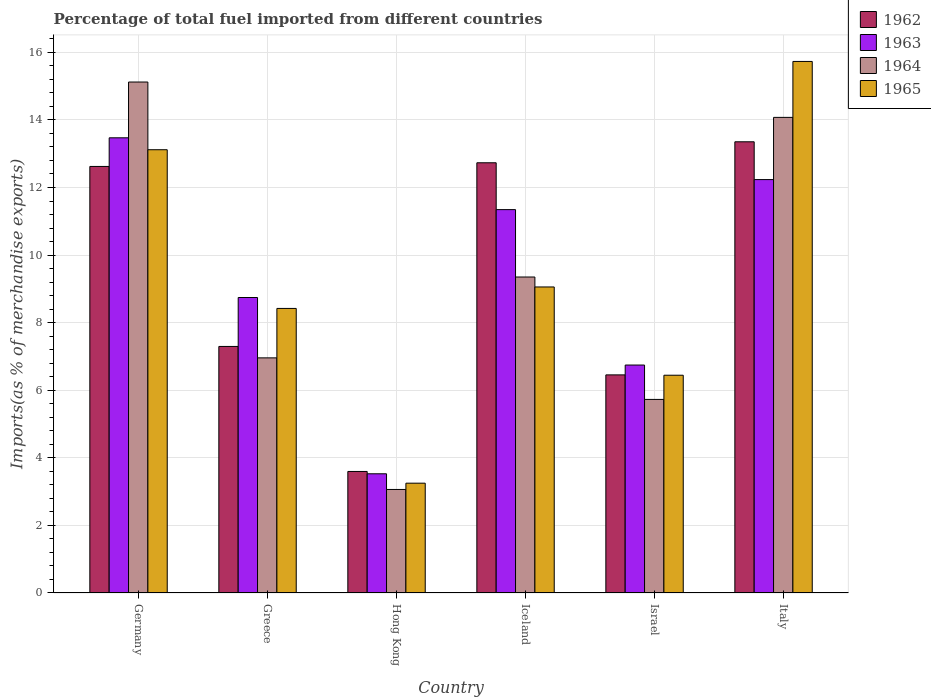How many different coloured bars are there?
Give a very brief answer. 4. How many groups of bars are there?
Your answer should be compact. 6. Are the number of bars per tick equal to the number of legend labels?
Offer a very short reply. Yes. Are the number of bars on each tick of the X-axis equal?
Your response must be concise. Yes. How many bars are there on the 2nd tick from the left?
Provide a short and direct response. 4. What is the label of the 4th group of bars from the left?
Make the answer very short. Iceland. What is the percentage of imports to different countries in 1964 in Greece?
Make the answer very short. 6.96. Across all countries, what is the maximum percentage of imports to different countries in 1964?
Provide a short and direct response. 15.12. Across all countries, what is the minimum percentage of imports to different countries in 1964?
Your answer should be compact. 3.06. In which country was the percentage of imports to different countries in 1962 minimum?
Offer a very short reply. Hong Kong. What is the total percentage of imports to different countries in 1962 in the graph?
Your answer should be very brief. 56.05. What is the difference between the percentage of imports to different countries in 1962 in Iceland and that in Italy?
Offer a very short reply. -0.62. What is the difference between the percentage of imports to different countries in 1965 in Israel and the percentage of imports to different countries in 1962 in Hong Kong?
Your answer should be very brief. 2.85. What is the average percentage of imports to different countries in 1965 per country?
Provide a short and direct response. 9.34. What is the difference between the percentage of imports to different countries of/in 1965 and percentage of imports to different countries of/in 1964 in Greece?
Your response must be concise. 1.46. What is the ratio of the percentage of imports to different countries in 1962 in Greece to that in Hong Kong?
Your answer should be compact. 2.03. Is the percentage of imports to different countries in 1962 in Germany less than that in Hong Kong?
Offer a very short reply. No. Is the difference between the percentage of imports to different countries in 1965 in Germany and Israel greater than the difference between the percentage of imports to different countries in 1964 in Germany and Israel?
Keep it short and to the point. No. What is the difference between the highest and the second highest percentage of imports to different countries in 1965?
Your answer should be very brief. -4.06. What is the difference between the highest and the lowest percentage of imports to different countries in 1964?
Ensure brevity in your answer.  12.06. In how many countries, is the percentage of imports to different countries in 1962 greater than the average percentage of imports to different countries in 1962 taken over all countries?
Your response must be concise. 3. Is it the case that in every country, the sum of the percentage of imports to different countries in 1963 and percentage of imports to different countries in 1965 is greater than the sum of percentage of imports to different countries in 1962 and percentage of imports to different countries in 1964?
Provide a short and direct response. No. What does the 2nd bar from the right in Israel represents?
Provide a short and direct response. 1964. Is it the case that in every country, the sum of the percentage of imports to different countries in 1963 and percentage of imports to different countries in 1965 is greater than the percentage of imports to different countries in 1964?
Your response must be concise. Yes. Are the values on the major ticks of Y-axis written in scientific E-notation?
Your response must be concise. No. Does the graph contain grids?
Ensure brevity in your answer.  Yes. How many legend labels are there?
Provide a short and direct response. 4. How are the legend labels stacked?
Your answer should be compact. Vertical. What is the title of the graph?
Your response must be concise. Percentage of total fuel imported from different countries. What is the label or title of the Y-axis?
Ensure brevity in your answer.  Imports(as % of merchandise exports). What is the Imports(as % of merchandise exports) in 1962 in Germany?
Your answer should be very brief. 12.62. What is the Imports(as % of merchandise exports) of 1963 in Germany?
Provide a succinct answer. 13.47. What is the Imports(as % of merchandise exports) of 1964 in Germany?
Your response must be concise. 15.12. What is the Imports(as % of merchandise exports) of 1965 in Germany?
Your response must be concise. 13.12. What is the Imports(as % of merchandise exports) of 1962 in Greece?
Your response must be concise. 7.3. What is the Imports(as % of merchandise exports) in 1963 in Greece?
Offer a very short reply. 8.74. What is the Imports(as % of merchandise exports) of 1964 in Greece?
Make the answer very short. 6.96. What is the Imports(as % of merchandise exports) in 1965 in Greece?
Keep it short and to the point. 8.42. What is the Imports(as % of merchandise exports) in 1962 in Hong Kong?
Provide a short and direct response. 3.6. What is the Imports(as % of merchandise exports) in 1963 in Hong Kong?
Offer a terse response. 3.53. What is the Imports(as % of merchandise exports) of 1964 in Hong Kong?
Offer a terse response. 3.06. What is the Imports(as % of merchandise exports) in 1965 in Hong Kong?
Your answer should be compact. 3.25. What is the Imports(as % of merchandise exports) of 1962 in Iceland?
Offer a very short reply. 12.73. What is the Imports(as % of merchandise exports) in 1963 in Iceland?
Your response must be concise. 11.35. What is the Imports(as % of merchandise exports) in 1964 in Iceland?
Give a very brief answer. 9.35. What is the Imports(as % of merchandise exports) of 1965 in Iceland?
Ensure brevity in your answer.  9.06. What is the Imports(as % of merchandise exports) of 1962 in Israel?
Make the answer very short. 6.45. What is the Imports(as % of merchandise exports) in 1963 in Israel?
Your answer should be very brief. 6.75. What is the Imports(as % of merchandise exports) of 1964 in Israel?
Provide a short and direct response. 5.73. What is the Imports(as % of merchandise exports) in 1965 in Israel?
Provide a succinct answer. 6.44. What is the Imports(as % of merchandise exports) of 1962 in Italy?
Provide a succinct answer. 13.35. What is the Imports(as % of merchandise exports) of 1963 in Italy?
Give a very brief answer. 12.23. What is the Imports(as % of merchandise exports) of 1964 in Italy?
Give a very brief answer. 14.07. What is the Imports(as % of merchandise exports) of 1965 in Italy?
Your response must be concise. 15.73. Across all countries, what is the maximum Imports(as % of merchandise exports) in 1962?
Your answer should be compact. 13.35. Across all countries, what is the maximum Imports(as % of merchandise exports) of 1963?
Your response must be concise. 13.47. Across all countries, what is the maximum Imports(as % of merchandise exports) of 1964?
Offer a terse response. 15.12. Across all countries, what is the maximum Imports(as % of merchandise exports) in 1965?
Your response must be concise. 15.73. Across all countries, what is the minimum Imports(as % of merchandise exports) in 1962?
Provide a succinct answer. 3.6. Across all countries, what is the minimum Imports(as % of merchandise exports) of 1963?
Provide a succinct answer. 3.53. Across all countries, what is the minimum Imports(as % of merchandise exports) in 1964?
Give a very brief answer. 3.06. Across all countries, what is the minimum Imports(as % of merchandise exports) of 1965?
Provide a short and direct response. 3.25. What is the total Imports(as % of merchandise exports) of 1962 in the graph?
Provide a succinct answer. 56.05. What is the total Imports(as % of merchandise exports) in 1963 in the graph?
Your answer should be compact. 56.07. What is the total Imports(as % of merchandise exports) of 1964 in the graph?
Make the answer very short. 54.3. What is the total Imports(as % of merchandise exports) of 1965 in the graph?
Provide a short and direct response. 56.02. What is the difference between the Imports(as % of merchandise exports) of 1962 in Germany and that in Greece?
Ensure brevity in your answer.  5.33. What is the difference between the Imports(as % of merchandise exports) of 1963 in Germany and that in Greece?
Give a very brief answer. 4.73. What is the difference between the Imports(as % of merchandise exports) of 1964 in Germany and that in Greece?
Your answer should be compact. 8.16. What is the difference between the Imports(as % of merchandise exports) of 1965 in Germany and that in Greece?
Offer a very short reply. 4.7. What is the difference between the Imports(as % of merchandise exports) of 1962 in Germany and that in Hong Kong?
Offer a very short reply. 9.03. What is the difference between the Imports(as % of merchandise exports) in 1963 in Germany and that in Hong Kong?
Provide a short and direct response. 9.94. What is the difference between the Imports(as % of merchandise exports) of 1964 in Germany and that in Hong Kong?
Give a very brief answer. 12.06. What is the difference between the Imports(as % of merchandise exports) in 1965 in Germany and that in Hong Kong?
Give a very brief answer. 9.87. What is the difference between the Imports(as % of merchandise exports) in 1962 in Germany and that in Iceland?
Make the answer very short. -0.11. What is the difference between the Imports(as % of merchandise exports) of 1963 in Germany and that in Iceland?
Offer a terse response. 2.13. What is the difference between the Imports(as % of merchandise exports) of 1964 in Germany and that in Iceland?
Your answer should be compact. 5.77. What is the difference between the Imports(as % of merchandise exports) of 1965 in Germany and that in Iceland?
Ensure brevity in your answer.  4.06. What is the difference between the Imports(as % of merchandise exports) of 1962 in Germany and that in Israel?
Your response must be concise. 6.17. What is the difference between the Imports(as % of merchandise exports) of 1963 in Germany and that in Israel?
Give a very brief answer. 6.72. What is the difference between the Imports(as % of merchandise exports) in 1964 in Germany and that in Israel?
Your response must be concise. 9.39. What is the difference between the Imports(as % of merchandise exports) in 1965 in Germany and that in Israel?
Offer a terse response. 6.67. What is the difference between the Imports(as % of merchandise exports) of 1962 in Germany and that in Italy?
Offer a very short reply. -0.73. What is the difference between the Imports(as % of merchandise exports) of 1963 in Germany and that in Italy?
Make the answer very short. 1.24. What is the difference between the Imports(as % of merchandise exports) of 1964 in Germany and that in Italy?
Your answer should be very brief. 1.05. What is the difference between the Imports(as % of merchandise exports) in 1965 in Germany and that in Italy?
Give a very brief answer. -2.61. What is the difference between the Imports(as % of merchandise exports) of 1962 in Greece and that in Hong Kong?
Offer a terse response. 3.7. What is the difference between the Imports(as % of merchandise exports) in 1963 in Greece and that in Hong Kong?
Make the answer very short. 5.22. What is the difference between the Imports(as % of merchandise exports) in 1964 in Greece and that in Hong Kong?
Ensure brevity in your answer.  3.89. What is the difference between the Imports(as % of merchandise exports) of 1965 in Greece and that in Hong Kong?
Ensure brevity in your answer.  5.17. What is the difference between the Imports(as % of merchandise exports) of 1962 in Greece and that in Iceland?
Offer a terse response. -5.44. What is the difference between the Imports(as % of merchandise exports) of 1963 in Greece and that in Iceland?
Keep it short and to the point. -2.6. What is the difference between the Imports(as % of merchandise exports) in 1964 in Greece and that in Iceland?
Your answer should be very brief. -2.39. What is the difference between the Imports(as % of merchandise exports) in 1965 in Greece and that in Iceland?
Your response must be concise. -0.64. What is the difference between the Imports(as % of merchandise exports) in 1962 in Greece and that in Israel?
Offer a terse response. 0.84. What is the difference between the Imports(as % of merchandise exports) of 1963 in Greece and that in Israel?
Give a very brief answer. 2. What is the difference between the Imports(as % of merchandise exports) in 1964 in Greece and that in Israel?
Give a very brief answer. 1.23. What is the difference between the Imports(as % of merchandise exports) of 1965 in Greece and that in Israel?
Your response must be concise. 1.98. What is the difference between the Imports(as % of merchandise exports) in 1962 in Greece and that in Italy?
Provide a succinct answer. -6.06. What is the difference between the Imports(as % of merchandise exports) of 1963 in Greece and that in Italy?
Offer a terse response. -3.49. What is the difference between the Imports(as % of merchandise exports) in 1964 in Greece and that in Italy?
Offer a terse response. -7.12. What is the difference between the Imports(as % of merchandise exports) of 1965 in Greece and that in Italy?
Give a very brief answer. -7.31. What is the difference between the Imports(as % of merchandise exports) of 1962 in Hong Kong and that in Iceland?
Your answer should be compact. -9.13. What is the difference between the Imports(as % of merchandise exports) in 1963 in Hong Kong and that in Iceland?
Make the answer very short. -7.82. What is the difference between the Imports(as % of merchandise exports) in 1964 in Hong Kong and that in Iceland?
Your response must be concise. -6.29. What is the difference between the Imports(as % of merchandise exports) of 1965 in Hong Kong and that in Iceland?
Offer a very short reply. -5.81. What is the difference between the Imports(as % of merchandise exports) of 1962 in Hong Kong and that in Israel?
Offer a very short reply. -2.86. What is the difference between the Imports(as % of merchandise exports) in 1963 in Hong Kong and that in Israel?
Offer a terse response. -3.22. What is the difference between the Imports(as % of merchandise exports) of 1964 in Hong Kong and that in Israel?
Your answer should be compact. -2.66. What is the difference between the Imports(as % of merchandise exports) of 1965 in Hong Kong and that in Israel?
Your response must be concise. -3.19. What is the difference between the Imports(as % of merchandise exports) of 1962 in Hong Kong and that in Italy?
Provide a short and direct response. -9.76. What is the difference between the Imports(as % of merchandise exports) of 1963 in Hong Kong and that in Italy?
Provide a succinct answer. -8.71. What is the difference between the Imports(as % of merchandise exports) of 1964 in Hong Kong and that in Italy?
Your answer should be compact. -11.01. What is the difference between the Imports(as % of merchandise exports) in 1965 in Hong Kong and that in Italy?
Your response must be concise. -12.48. What is the difference between the Imports(as % of merchandise exports) in 1962 in Iceland and that in Israel?
Your answer should be compact. 6.28. What is the difference between the Imports(as % of merchandise exports) of 1963 in Iceland and that in Israel?
Ensure brevity in your answer.  4.6. What is the difference between the Imports(as % of merchandise exports) in 1964 in Iceland and that in Israel?
Your response must be concise. 3.62. What is the difference between the Imports(as % of merchandise exports) in 1965 in Iceland and that in Israel?
Your answer should be very brief. 2.61. What is the difference between the Imports(as % of merchandise exports) of 1962 in Iceland and that in Italy?
Your answer should be compact. -0.62. What is the difference between the Imports(as % of merchandise exports) in 1963 in Iceland and that in Italy?
Offer a terse response. -0.89. What is the difference between the Imports(as % of merchandise exports) of 1964 in Iceland and that in Italy?
Offer a terse response. -4.72. What is the difference between the Imports(as % of merchandise exports) in 1965 in Iceland and that in Italy?
Provide a succinct answer. -6.67. What is the difference between the Imports(as % of merchandise exports) in 1962 in Israel and that in Italy?
Keep it short and to the point. -6.9. What is the difference between the Imports(as % of merchandise exports) in 1963 in Israel and that in Italy?
Make the answer very short. -5.49. What is the difference between the Imports(as % of merchandise exports) of 1964 in Israel and that in Italy?
Your answer should be very brief. -8.35. What is the difference between the Imports(as % of merchandise exports) in 1965 in Israel and that in Italy?
Provide a succinct answer. -9.29. What is the difference between the Imports(as % of merchandise exports) of 1962 in Germany and the Imports(as % of merchandise exports) of 1963 in Greece?
Your answer should be compact. 3.88. What is the difference between the Imports(as % of merchandise exports) of 1962 in Germany and the Imports(as % of merchandise exports) of 1964 in Greece?
Ensure brevity in your answer.  5.66. What is the difference between the Imports(as % of merchandise exports) in 1962 in Germany and the Imports(as % of merchandise exports) in 1965 in Greece?
Offer a very short reply. 4.2. What is the difference between the Imports(as % of merchandise exports) in 1963 in Germany and the Imports(as % of merchandise exports) in 1964 in Greece?
Your answer should be compact. 6.51. What is the difference between the Imports(as % of merchandise exports) of 1963 in Germany and the Imports(as % of merchandise exports) of 1965 in Greece?
Keep it short and to the point. 5.05. What is the difference between the Imports(as % of merchandise exports) in 1964 in Germany and the Imports(as % of merchandise exports) in 1965 in Greece?
Offer a terse response. 6.7. What is the difference between the Imports(as % of merchandise exports) of 1962 in Germany and the Imports(as % of merchandise exports) of 1963 in Hong Kong?
Keep it short and to the point. 9.1. What is the difference between the Imports(as % of merchandise exports) of 1962 in Germany and the Imports(as % of merchandise exports) of 1964 in Hong Kong?
Your answer should be very brief. 9.56. What is the difference between the Imports(as % of merchandise exports) in 1962 in Germany and the Imports(as % of merchandise exports) in 1965 in Hong Kong?
Give a very brief answer. 9.37. What is the difference between the Imports(as % of merchandise exports) of 1963 in Germany and the Imports(as % of merchandise exports) of 1964 in Hong Kong?
Your answer should be very brief. 10.41. What is the difference between the Imports(as % of merchandise exports) of 1963 in Germany and the Imports(as % of merchandise exports) of 1965 in Hong Kong?
Ensure brevity in your answer.  10.22. What is the difference between the Imports(as % of merchandise exports) of 1964 in Germany and the Imports(as % of merchandise exports) of 1965 in Hong Kong?
Give a very brief answer. 11.87. What is the difference between the Imports(as % of merchandise exports) of 1962 in Germany and the Imports(as % of merchandise exports) of 1963 in Iceland?
Your answer should be very brief. 1.28. What is the difference between the Imports(as % of merchandise exports) in 1962 in Germany and the Imports(as % of merchandise exports) in 1964 in Iceland?
Make the answer very short. 3.27. What is the difference between the Imports(as % of merchandise exports) of 1962 in Germany and the Imports(as % of merchandise exports) of 1965 in Iceland?
Provide a short and direct response. 3.57. What is the difference between the Imports(as % of merchandise exports) of 1963 in Germany and the Imports(as % of merchandise exports) of 1964 in Iceland?
Offer a terse response. 4.12. What is the difference between the Imports(as % of merchandise exports) of 1963 in Germany and the Imports(as % of merchandise exports) of 1965 in Iceland?
Your answer should be very brief. 4.41. What is the difference between the Imports(as % of merchandise exports) in 1964 in Germany and the Imports(as % of merchandise exports) in 1965 in Iceland?
Offer a very short reply. 6.06. What is the difference between the Imports(as % of merchandise exports) in 1962 in Germany and the Imports(as % of merchandise exports) in 1963 in Israel?
Ensure brevity in your answer.  5.88. What is the difference between the Imports(as % of merchandise exports) of 1962 in Germany and the Imports(as % of merchandise exports) of 1964 in Israel?
Offer a very short reply. 6.89. What is the difference between the Imports(as % of merchandise exports) of 1962 in Germany and the Imports(as % of merchandise exports) of 1965 in Israel?
Offer a terse response. 6.18. What is the difference between the Imports(as % of merchandise exports) in 1963 in Germany and the Imports(as % of merchandise exports) in 1964 in Israel?
Offer a very short reply. 7.74. What is the difference between the Imports(as % of merchandise exports) in 1963 in Germany and the Imports(as % of merchandise exports) in 1965 in Israel?
Provide a succinct answer. 7.03. What is the difference between the Imports(as % of merchandise exports) of 1964 in Germany and the Imports(as % of merchandise exports) of 1965 in Israel?
Your response must be concise. 8.68. What is the difference between the Imports(as % of merchandise exports) of 1962 in Germany and the Imports(as % of merchandise exports) of 1963 in Italy?
Offer a terse response. 0.39. What is the difference between the Imports(as % of merchandise exports) of 1962 in Germany and the Imports(as % of merchandise exports) of 1964 in Italy?
Your answer should be compact. -1.45. What is the difference between the Imports(as % of merchandise exports) in 1962 in Germany and the Imports(as % of merchandise exports) in 1965 in Italy?
Ensure brevity in your answer.  -3.11. What is the difference between the Imports(as % of merchandise exports) of 1963 in Germany and the Imports(as % of merchandise exports) of 1964 in Italy?
Provide a succinct answer. -0.6. What is the difference between the Imports(as % of merchandise exports) in 1963 in Germany and the Imports(as % of merchandise exports) in 1965 in Italy?
Offer a very short reply. -2.26. What is the difference between the Imports(as % of merchandise exports) of 1964 in Germany and the Imports(as % of merchandise exports) of 1965 in Italy?
Your answer should be compact. -0.61. What is the difference between the Imports(as % of merchandise exports) of 1962 in Greece and the Imports(as % of merchandise exports) of 1963 in Hong Kong?
Give a very brief answer. 3.77. What is the difference between the Imports(as % of merchandise exports) of 1962 in Greece and the Imports(as % of merchandise exports) of 1964 in Hong Kong?
Your answer should be compact. 4.23. What is the difference between the Imports(as % of merchandise exports) of 1962 in Greece and the Imports(as % of merchandise exports) of 1965 in Hong Kong?
Make the answer very short. 4.05. What is the difference between the Imports(as % of merchandise exports) of 1963 in Greece and the Imports(as % of merchandise exports) of 1964 in Hong Kong?
Give a very brief answer. 5.68. What is the difference between the Imports(as % of merchandise exports) in 1963 in Greece and the Imports(as % of merchandise exports) in 1965 in Hong Kong?
Give a very brief answer. 5.49. What is the difference between the Imports(as % of merchandise exports) of 1964 in Greece and the Imports(as % of merchandise exports) of 1965 in Hong Kong?
Offer a terse response. 3.71. What is the difference between the Imports(as % of merchandise exports) in 1962 in Greece and the Imports(as % of merchandise exports) in 1963 in Iceland?
Ensure brevity in your answer.  -4.05. What is the difference between the Imports(as % of merchandise exports) in 1962 in Greece and the Imports(as % of merchandise exports) in 1964 in Iceland?
Give a very brief answer. -2.06. What is the difference between the Imports(as % of merchandise exports) in 1962 in Greece and the Imports(as % of merchandise exports) in 1965 in Iceland?
Make the answer very short. -1.76. What is the difference between the Imports(as % of merchandise exports) in 1963 in Greece and the Imports(as % of merchandise exports) in 1964 in Iceland?
Provide a succinct answer. -0.61. What is the difference between the Imports(as % of merchandise exports) in 1963 in Greece and the Imports(as % of merchandise exports) in 1965 in Iceland?
Keep it short and to the point. -0.31. What is the difference between the Imports(as % of merchandise exports) in 1964 in Greece and the Imports(as % of merchandise exports) in 1965 in Iceland?
Give a very brief answer. -2.1. What is the difference between the Imports(as % of merchandise exports) of 1962 in Greece and the Imports(as % of merchandise exports) of 1963 in Israel?
Your answer should be very brief. 0.55. What is the difference between the Imports(as % of merchandise exports) in 1962 in Greece and the Imports(as % of merchandise exports) in 1964 in Israel?
Offer a very short reply. 1.57. What is the difference between the Imports(as % of merchandise exports) of 1962 in Greece and the Imports(as % of merchandise exports) of 1965 in Israel?
Offer a very short reply. 0.85. What is the difference between the Imports(as % of merchandise exports) of 1963 in Greece and the Imports(as % of merchandise exports) of 1964 in Israel?
Provide a short and direct response. 3.02. What is the difference between the Imports(as % of merchandise exports) in 1964 in Greece and the Imports(as % of merchandise exports) in 1965 in Israel?
Your answer should be compact. 0.51. What is the difference between the Imports(as % of merchandise exports) in 1962 in Greece and the Imports(as % of merchandise exports) in 1963 in Italy?
Offer a very short reply. -4.94. What is the difference between the Imports(as % of merchandise exports) in 1962 in Greece and the Imports(as % of merchandise exports) in 1964 in Italy?
Provide a short and direct response. -6.78. What is the difference between the Imports(as % of merchandise exports) in 1962 in Greece and the Imports(as % of merchandise exports) in 1965 in Italy?
Keep it short and to the point. -8.43. What is the difference between the Imports(as % of merchandise exports) of 1963 in Greece and the Imports(as % of merchandise exports) of 1964 in Italy?
Offer a terse response. -5.33. What is the difference between the Imports(as % of merchandise exports) of 1963 in Greece and the Imports(as % of merchandise exports) of 1965 in Italy?
Offer a terse response. -6.99. What is the difference between the Imports(as % of merchandise exports) of 1964 in Greece and the Imports(as % of merchandise exports) of 1965 in Italy?
Your answer should be very brief. -8.77. What is the difference between the Imports(as % of merchandise exports) in 1962 in Hong Kong and the Imports(as % of merchandise exports) in 1963 in Iceland?
Your response must be concise. -7.75. What is the difference between the Imports(as % of merchandise exports) of 1962 in Hong Kong and the Imports(as % of merchandise exports) of 1964 in Iceland?
Ensure brevity in your answer.  -5.75. What is the difference between the Imports(as % of merchandise exports) of 1962 in Hong Kong and the Imports(as % of merchandise exports) of 1965 in Iceland?
Provide a succinct answer. -5.46. What is the difference between the Imports(as % of merchandise exports) in 1963 in Hong Kong and the Imports(as % of merchandise exports) in 1964 in Iceland?
Make the answer very short. -5.82. What is the difference between the Imports(as % of merchandise exports) in 1963 in Hong Kong and the Imports(as % of merchandise exports) in 1965 in Iceland?
Provide a short and direct response. -5.53. What is the difference between the Imports(as % of merchandise exports) in 1964 in Hong Kong and the Imports(as % of merchandise exports) in 1965 in Iceland?
Keep it short and to the point. -5.99. What is the difference between the Imports(as % of merchandise exports) in 1962 in Hong Kong and the Imports(as % of merchandise exports) in 1963 in Israel?
Provide a short and direct response. -3.15. What is the difference between the Imports(as % of merchandise exports) in 1962 in Hong Kong and the Imports(as % of merchandise exports) in 1964 in Israel?
Offer a very short reply. -2.13. What is the difference between the Imports(as % of merchandise exports) in 1962 in Hong Kong and the Imports(as % of merchandise exports) in 1965 in Israel?
Make the answer very short. -2.85. What is the difference between the Imports(as % of merchandise exports) of 1963 in Hong Kong and the Imports(as % of merchandise exports) of 1964 in Israel?
Your answer should be compact. -2.2. What is the difference between the Imports(as % of merchandise exports) in 1963 in Hong Kong and the Imports(as % of merchandise exports) in 1965 in Israel?
Your answer should be very brief. -2.92. What is the difference between the Imports(as % of merchandise exports) in 1964 in Hong Kong and the Imports(as % of merchandise exports) in 1965 in Israel?
Provide a succinct answer. -3.38. What is the difference between the Imports(as % of merchandise exports) in 1962 in Hong Kong and the Imports(as % of merchandise exports) in 1963 in Italy?
Offer a terse response. -8.64. What is the difference between the Imports(as % of merchandise exports) in 1962 in Hong Kong and the Imports(as % of merchandise exports) in 1964 in Italy?
Provide a short and direct response. -10.48. What is the difference between the Imports(as % of merchandise exports) of 1962 in Hong Kong and the Imports(as % of merchandise exports) of 1965 in Italy?
Offer a very short reply. -12.13. What is the difference between the Imports(as % of merchandise exports) of 1963 in Hong Kong and the Imports(as % of merchandise exports) of 1964 in Italy?
Provide a succinct answer. -10.55. What is the difference between the Imports(as % of merchandise exports) of 1963 in Hong Kong and the Imports(as % of merchandise exports) of 1965 in Italy?
Offer a terse response. -12.2. What is the difference between the Imports(as % of merchandise exports) of 1964 in Hong Kong and the Imports(as % of merchandise exports) of 1965 in Italy?
Make the answer very short. -12.67. What is the difference between the Imports(as % of merchandise exports) of 1962 in Iceland and the Imports(as % of merchandise exports) of 1963 in Israel?
Provide a short and direct response. 5.99. What is the difference between the Imports(as % of merchandise exports) in 1962 in Iceland and the Imports(as % of merchandise exports) in 1964 in Israel?
Ensure brevity in your answer.  7. What is the difference between the Imports(as % of merchandise exports) of 1962 in Iceland and the Imports(as % of merchandise exports) of 1965 in Israel?
Give a very brief answer. 6.29. What is the difference between the Imports(as % of merchandise exports) of 1963 in Iceland and the Imports(as % of merchandise exports) of 1964 in Israel?
Your response must be concise. 5.62. What is the difference between the Imports(as % of merchandise exports) of 1963 in Iceland and the Imports(as % of merchandise exports) of 1965 in Israel?
Provide a short and direct response. 4.9. What is the difference between the Imports(as % of merchandise exports) of 1964 in Iceland and the Imports(as % of merchandise exports) of 1965 in Israel?
Provide a succinct answer. 2.91. What is the difference between the Imports(as % of merchandise exports) of 1962 in Iceland and the Imports(as % of merchandise exports) of 1963 in Italy?
Your response must be concise. 0.5. What is the difference between the Imports(as % of merchandise exports) of 1962 in Iceland and the Imports(as % of merchandise exports) of 1964 in Italy?
Ensure brevity in your answer.  -1.34. What is the difference between the Imports(as % of merchandise exports) in 1962 in Iceland and the Imports(as % of merchandise exports) in 1965 in Italy?
Ensure brevity in your answer.  -3. What is the difference between the Imports(as % of merchandise exports) in 1963 in Iceland and the Imports(as % of merchandise exports) in 1964 in Italy?
Your answer should be very brief. -2.73. What is the difference between the Imports(as % of merchandise exports) of 1963 in Iceland and the Imports(as % of merchandise exports) of 1965 in Italy?
Make the answer very short. -4.38. What is the difference between the Imports(as % of merchandise exports) of 1964 in Iceland and the Imports(as % of merchandise exports) of 1965 in Italy?
Keep it short and to the point. -6.38. What is the difference between the Imports(as % of merchandise exports) of 1962 in Israel and the Imports(as % of merchandise exports) of 1963 in Italy?
Make the answer very short. -5.78. What is the difference between the Imports(as % of merchandise exports) of 1962 in Israel and the Imports(as % of merchandise exports) of 1964 in Italy?
Provide a succinct answer. -7.62. What is the difference between the Imports(as % of merchandise exports) of 1962 in Israel and the Imports(as % of merchandise exports) of 1965 in Italy?
Provide a succinct answer. -9.28. What is the difference between the Imports(as % of merchandise exports) in 1963 in Israel and the Imports(as % of merchandise exports) in 1964 in Italy?
Your response must be concise. -7.33. What is the difference between the Imports(as % of merchandise exports) in 1963 in Israel and the Imports(as % of merchandise exports) in 1965 in Italy?
Your answer should be compact. -8.98. What is the difference between the Imports(as % of merchandise exports) of 1964 in Israel and the Imports(as % of merchandise exports) of 1965 in Italy?
Give a very brief answer. -10. What is the average Imports(as % of merchandise exports) of 1962 per country?
Provide a succinct answer. 9.34. What is the average Imports(as % of merchandise exports) in 1963 per country?
Ensure brevity in your answer.  9.34. What is the average Imports(as % of merchandise exports) in 1964 per country?
Make the answer very short. 9.05. What is the average Imports(as % of merchandise exports) of 1965 per country?
Keep it short and to the point. 9.34. What is the difference between the Imports(as % of merchandise exports) of 1962 and Imports(as % of merchandise exports) of 1963 in Germany?
Keep it short and to the point. -0.85. What is the difference between the Imports(as % of merchandise exports) in 1962 and Imports(as % of merchandise exports) in 1964 in Germany?
Provide a short and direct response. -2.5. What is the difference between the Imports(as % of merchandise exports) of 1962 and Imports(as % of merchandise exports) of 1965 in Germany?
Your answer should be compact. -0.49. What is the difference between the Imports(as % of merchandise exports) of 1963 and Imports(as % of merchandise exports) of 1964 in Germany?
Provide a succinct answer. -1.65. What is the difference between the Imports(as % of merchandise exports) in 1963 and Imports(as % of merchandise exports) in 1965 in Germany?
Provide a short and direct response. 0.35. What is the difference between the Imports(as % of merchandise exports) of 1964 and Imports(as % of merchandise exports) of 1965 in Germany?
Give a very brief answer. 2. What is the difference between the Imports(as % of merchandise exports) of 1962 and Imports(as % of merchandise exports) of 1963 in Greece?
Provide a succinct answer. -1.45. What is the difference between the Imports(as % of merchandise exports) of 1962 and Imports(as % of merchandise exports) of 1964 in Greece?
Offer a very short reply. 0.34. What is the difference between the Imports(as % of merchandise exports) in 1962 and Imports(as % of merchandise exports) in 1965 in Greece?
Ensure brevity in your answer.  -1.13. What is the difference between the Imports(as % of merchandise exports) of 1963 and Imports(as % of merchandise exports) of 1964 in Greece?
Ensure brevity in your answer.  1.79. What is the difference between the Imports(as % of merchandise exports) in 1963 and Imports(as % of merchandise exports) in 1965 in Greece?
Offer a very short reply. 0.32. What is the difference between the Imports(as % of merchandise exports) in 1964 and Imports(as % of merchandise exports) in 1965 in Greece?
Give a very brief answer. -1.46. What is the difference between the Imports(as % of merchandise exports) in 1962 and Imports(as % of merchandise exports) in 1963 in Hong Kong?
Offer a very short reply. 0.07. What is the difference between the Imports(as % of merchandise exports) of 1962 and Imports(as % of merchandise exports) of 1964 in Hong Kong?
Give a very brief answer. 0.53. What is the difference between the Imports(as % of merchandise exports) in 1962 and Imports(as % of merchandise exports) in 1965 in Hong Kong?
Offer a very short reply. 0.35. What is the difference between the Imports(as % of merchandise exports) of 1963 and Imports(as % of merchandise exports) of 1964 in Hong Kong?
Give a very brief answer. 0.46. What is the difference between the Imports(as % of merchandise exports) in 1963 and Imports(as % of merchandise exports) in 1965 in Hong Kong?
Your answer should be compact. 0.28. What is the difference between the Imports(as % of merchandise exports) of 1964 and Imports(as % of merchandise exports) of 1965 in Hong Kong?
Your response must be concise. -0.19. What is the difference between the Imports(as % of merchandise exports) of 1962 and Imports(as % of merchandise exports) of 1963 in Iceland?
Your response must be concise. 1.39. What is the difference between the Imports(as % of merchandise exports) in 1962 and Imports(as % of merchandise exports) in 1964 in Iceland?
Give a very brief answer. 3.38. What is the difference between the Imports(as % of merchandise exports) of 1962 and Imports(as % of merchandise exports) of 1965 in Iceland?
Make the answer very short. 3.67. What is the difference between the Imports(as % of merchandise exports) of 1963 and Imports(as % of merchandise exports) of 1964 in Iceland?
Offer a very short reply. 1.99. What is the difference between the Imports(as % of merchandise exports) of 1963 and Imports(as % of merchandise exports) of 1965 in Iceland?
Your response must be concise. 2.29. What is the difference between the Imports(as % of merchandise exports) of 1964 and Imports(as % of merchandise exports) of 1965 in Iceland?
Your answer should be very brief. 0.29. What is the difference between the Imports(as % of merchandise exports) of 1962 and Imports(as % of merchandise exports) of 1963 in Israel?
Provide a succinct answer. -0.29. What is the difference between the Imports(as % of merchandise exports) of 1962 and Imports(as % of merchandise exports) of 1964 in Israel?
Provide a succinct answer. 0.73. What is the difference between the Imports(as % of merchandise exports) of 1962 and Imports(as % of merchandise exports) of 1965 in Israel?
Offer a terse response. 0.01. What is the difference between the Imports(as % of merchandise exports) in 1963 and Imports(as % of merchandise exports) in 1964 in Israel?
Your response must be concise. 1.02. What is the difference between the Imports(as % of merchandise exports) in 1963 and Imports(as % of merchandise exports) in 1965 in Israel?
Offer a terse response. 0.3. What is the difference between the Imports(as % of merchandise exports) in 1964 and Imports(as % of merchandise exports) in 1965 in Israel?
Ensure brevity in your answer.  -0.72. What is the difference between the Imports(as % of merchandise exports) of 1962 and Imports(as % of merchandise exports) of 1963 in Italy?
Provide a succinct answer. 1.12. What is the difference between the Imports(as % of merchandise exports) of 1962 and Imports(as % of merchandise exports) of 1964 in Italy?
Provide a short and direct response. -0.72. What is the difference between the Imports(as % of merchandise exports) in 1962 and Imports(as % of merchandise exports) in 1965 in Italy?
Keep it short and to the point. -2.38. What is the difference between the Imports(as % of merchandise exports) in 1963 and Imports(as % of merchandise exports) in 1964 in Italy?
Offer a terse response. -1.84. What is the difference between the Imports(as % of merchandise exports) of 1963 and Imports(as % of merchandise exports) of 1965 in Italy?
Your answer should be compact. -3.5. What is the difference between the Imports(as % of merchandise exports) in 1964 and Imports(as % of merchandise exports) in 1965 in Italy?
Ensure brevity in your answer.  -1.65. What is the ratio of the Imports(as % of merchandise exports) in 1962 in Germany to that in Greece?
Your answer should be very brief. 1.73. What is the ratio of the Imports(as % of merchandise exports) in 1963 in Germany to that in Greece?
Ensure brevity in your answer.  1.54. What is the ratio of the Imports(as % of merchandise exports) in 1964 in Germany to that in Greece?
Provide a succinct answer. 2.17. What is the ratio of the Imports(as % of merchandise exports) in 1965 in Germany to that in Greece?
Offer a very short reply. 1.56. What is the ratio of the Imports(as % of merchandise exports) of 1962 in Germany to that in Hong Kong?
Your answer should be compact. 3.51. What is the ratio of the Imports(as % of merchandise exports) in 1963 in Germany to that in Hong Kong?
Provide a succinct answer. 3.82. What is the ratio of the Imports(as % of merchandise exports) of 1964 in Germany to that in Hong Kong?
Offer a very short reply. 4.94. What is the ratio of the Imports(as % of merchandise exports) of 1965 in Germany to that in Hong Kong?
Ensure brevity in your answer.  4.04. What is the ratio of the Imports(as % of merchandise exports) in 1963 in Germany to that in Iceland?
Keep it short and to the point. 1.19. What is the ratio of the Imports(as % of merchandise exports) in 1964 in Germany to that in Iceland?
Your answer should be very brief. 1.62. What is the ratio of the Imports(as % of merchandise exports) of 1965 in Germany to that in Iceland?
Make the answer very short. 1.45. What is the ratio of the Imports(as % of merchandise exports) in 1962 in Germany to that in Israel?
Give a very brief answer. 1.96. What is the ratio of the Imports(as % of merchandise exports) of 1963 in Germany to that in Israel?
Provide a short and direct response. 2. What is the ratio of the Imports(as % of merchandise exports) of 1964 in Germany to that in Israel?
Keep it short and to the point. 2.64. What is the ratio of the Imports(as % of merchandise exports) in 1965 in Germany to that in Israel?
Make the answer very short. 2.04. What is the ratio of the Imports(as % of merchandise exports) of 1962 in Germany to that in Italy?
Offer a terse response. 0.95. What is the ratio of the Imports(as % of merchandise exports) in 1963 in Germany to that in Italy?
Offer a terse response. 1.1. What is the ratio of the Imports(as % of merchandise exports) in 1964 in Germany to that in Italy?
Your response must be concise. 1.07. What is the ratio of the Imports(as % of merchandise exports) of 1965 in Germany to that in Italy?
Ensure brevity in your answer.  0.83. What is the ratio of the Imports(as % of merchandise exports) of 1962 in Greece to that in Hong Kong?
Make the answer very short. 2.03. What is the ratio of the Imports(as % of merchandise exports) in 1963 in Greece to that in Hong Kong?
Make the answer very short. 2.48. What is the ratio of the Imports(as % of merchandise exports) in 1964 in Greece to that in Hong Kong?
Give a very brief answer. 2.27. What is the ratio of the Imports(as % of merchandise exports) in 1965 in Greece to that in Hong Kong?
Make the answer very short. 2.59. What is the ratio of the Imports(as % of merchandise exports) of 1962 in Greece to that in Iceland?
Provide a succinct answer. 0.57. What is the ratio of the Imports(as % of merchandise exports) in 1963 in Greece to that in Iceland?
Offer a terse response. 0.77. What is the ratio of the Imports(as % of merchandise exports) in 1964 in Greece to that in Iceland?
Provide a succinct answer. 0.74. What is the ratio of the Imports(as % of merchandise exports) in 1965 in Greece to that in Iceland?
Your answer should be compact. 0.93. What is the ratio of the Imports(as % of merchandise exports) in 1962 in Greece to that in Israel?
Make the answer very short. 1.13. What is the ratio of the Imports(as % of merchandise exports) in 1963 in Greece to that in Israel?
Keep it short and to the point. 1.3. What is the ratio of the Imports(as % of merchandise exports) in 1964 in Greece to that in Israel?
Provide a succinct answer. 1.21. What is the ratio of the Imports(as % of merchandise exports) in 1965 in Greece to that in Israel?
Ensure brevity in your answer.  1.31. What is the ratio of the Imports(as % of merchandise exports) of 1962 in Greece to that in Italy?
Give a very brief answer. 0.55. What is the ratio of the Imports(as % of merchandise exports) in 1963 in Greece to that in Italy?
Offer a terse response. 0.71. What is the ratio of the Imports(as % of merchandise exports) in 1964 in Greece to that in Italy?
Provide a succinct answer. 0.49. What is the ratio of the Imports(as % of merchandise exports) of 1965 in Greece to that in Italy?
Provide a short and direct response. 0.54. What is the ratio of the Imports(as % of merchandise exports) of 1962 in Hong Kong to that in Iceland?
Your response must be concise. 0.28. What is the ratio of the Imports(as % of merchandise exports) of 1963 in Hong Kong to that in Iceland?
Offer a very short reply. 0.31. What is the ratio of the Imports(as % of merchandise exports) in 1964 in Hong Kong to that in Iceland?
Your response must be concise. 0.33. What is the ratio of the Imports(as % of merchandise exports) in 1965 in Hong Kong to that in Iceland?
Make the answer very short. 0.36. What is the ratio of the Imports(as % of merchandise exports) in 1962 in Hong Kong to that in Israel?
Your answer should be very brief. 0.56. What is the ratio of the Imports(as % of merchandise exports) in 1963 in Hong Kong to that in Israel?
Your answer should be very brief. 0.52. What is the ratio of the Imports(as % of merchandise exports) in 1964 in Hong Kong to that in Israel?
Ensure brevity in your answer.  0.53. What is the ratio of the Imports(as % of merchandise exports) of 1965 in Hong Kong to that in Israel?
Give a very brief answer. 0.5. What is the ratio of the Imports(as % of merchandise exports) of 1962 in Hong Kong to that in Italy?
Make the answer very short. 0.27. What is the ratio of the Imports(as % of merchandise exports) of 1963 in Hong Kong to that in Italy?
Offer a very short reply. 0.29. What is the ratio of the Imports(as % of merchandise exports) in 1964 in Hong Kong to that in Italy?
Offer a very short reply. 0.22. What is the ratio of the Imports(as % of merchandise exports) in 1965 in Hong Kong to that in Italy?
Make the answer very short. 0.21. What is the ratio of the Imports(as % of merchandise exports) in 1962 in Iceland to that in Israel?
Keep it short and to the point. 1.97. What is the ratio of the Imports(as % of merchandise exports) of 1963 in Iceland to that in Israel?
Offer a very short reply. 1.68. What is the ratio of the Imports(as % of merchandise exports) of 1964 in Iceland to that in Israel?
Provide a short and direct response. 1.63. What is the ratio of the Imports(as % of merchandise exports) of 1965 in Iceland to that in Israel?
Your answer should be very brief. 1.41. What is the ratio of the Imports(as % of merchandise exports) of 1962 in Iceland to that in Italy?
Give a very brief answer. 0.95. What is the ratio of the Imports(as % of merchandise exports) of 1963 in Iceland to that in Italy?
Provide a succinct answer. 0.93. What is the ratio of the Imports(as % of merchandise exports) in 1964 in Iceland to that in Italy?
Ensure brevity in your answer.  0.66. What is the ratio of the Imports(as % of merchandise exports) of 1965 in Iceland to that in Italy?
Your answer should be very brief. 0.58. What is the ratio of the Imports(as % of merchandise exports) of 1962 in Israel to that in Italy?
Give a very brief answer. 0.48. What is the ratio of the Imports(as % of merchandise exports) in 1963 in Israel to that in Italy?
Provide a short and direct response. 0.55. What is the ratio of the Imports(as % of merchandise exports) in 1964 in Israel to that in Italy?
Your answer should be very brief. 0.41. What is the ratio of the Imports(as % of merchandise exports) of 1965 in Israel to that in Italy?
Ensure brevity in your answer.  0.41. What is the difference between the highest and the second highest Imports(as % of merchandise exports) of 1962?
Provide a short and direct response. 0.62. What is the difference between the highest and the second highest Imports(as % of merchandise exports) of 1963?
Offer a terse response. 1.24. What is the difference between the highest and the second highest Imports(as % of merchandise exports) in 1964?
Ensure brevity in your answer.  1.05. What is the difference between the highest and the second highest Imports(as % of merchandise exports) in 1965?
Make the answer very short. 2.61. What is the difference between the highest and the lowest Imports(as % of merchandise exports) of 1962?
Provide a succinct answer. 9.76. What is the difference between the highest and the lowest Imports(as % of merchandise exports) of 1963?
Give a very brief answer. 9.94. What is the difference between the highest and the lowest Imports(as % of merchandise exports) in 1964?
Offer a very short reply. 12.06. What is the difference between the highest and the lowest Imports(as % of merchandise exports) in 1965?
Ensure brevity in your answer.  12.48. 